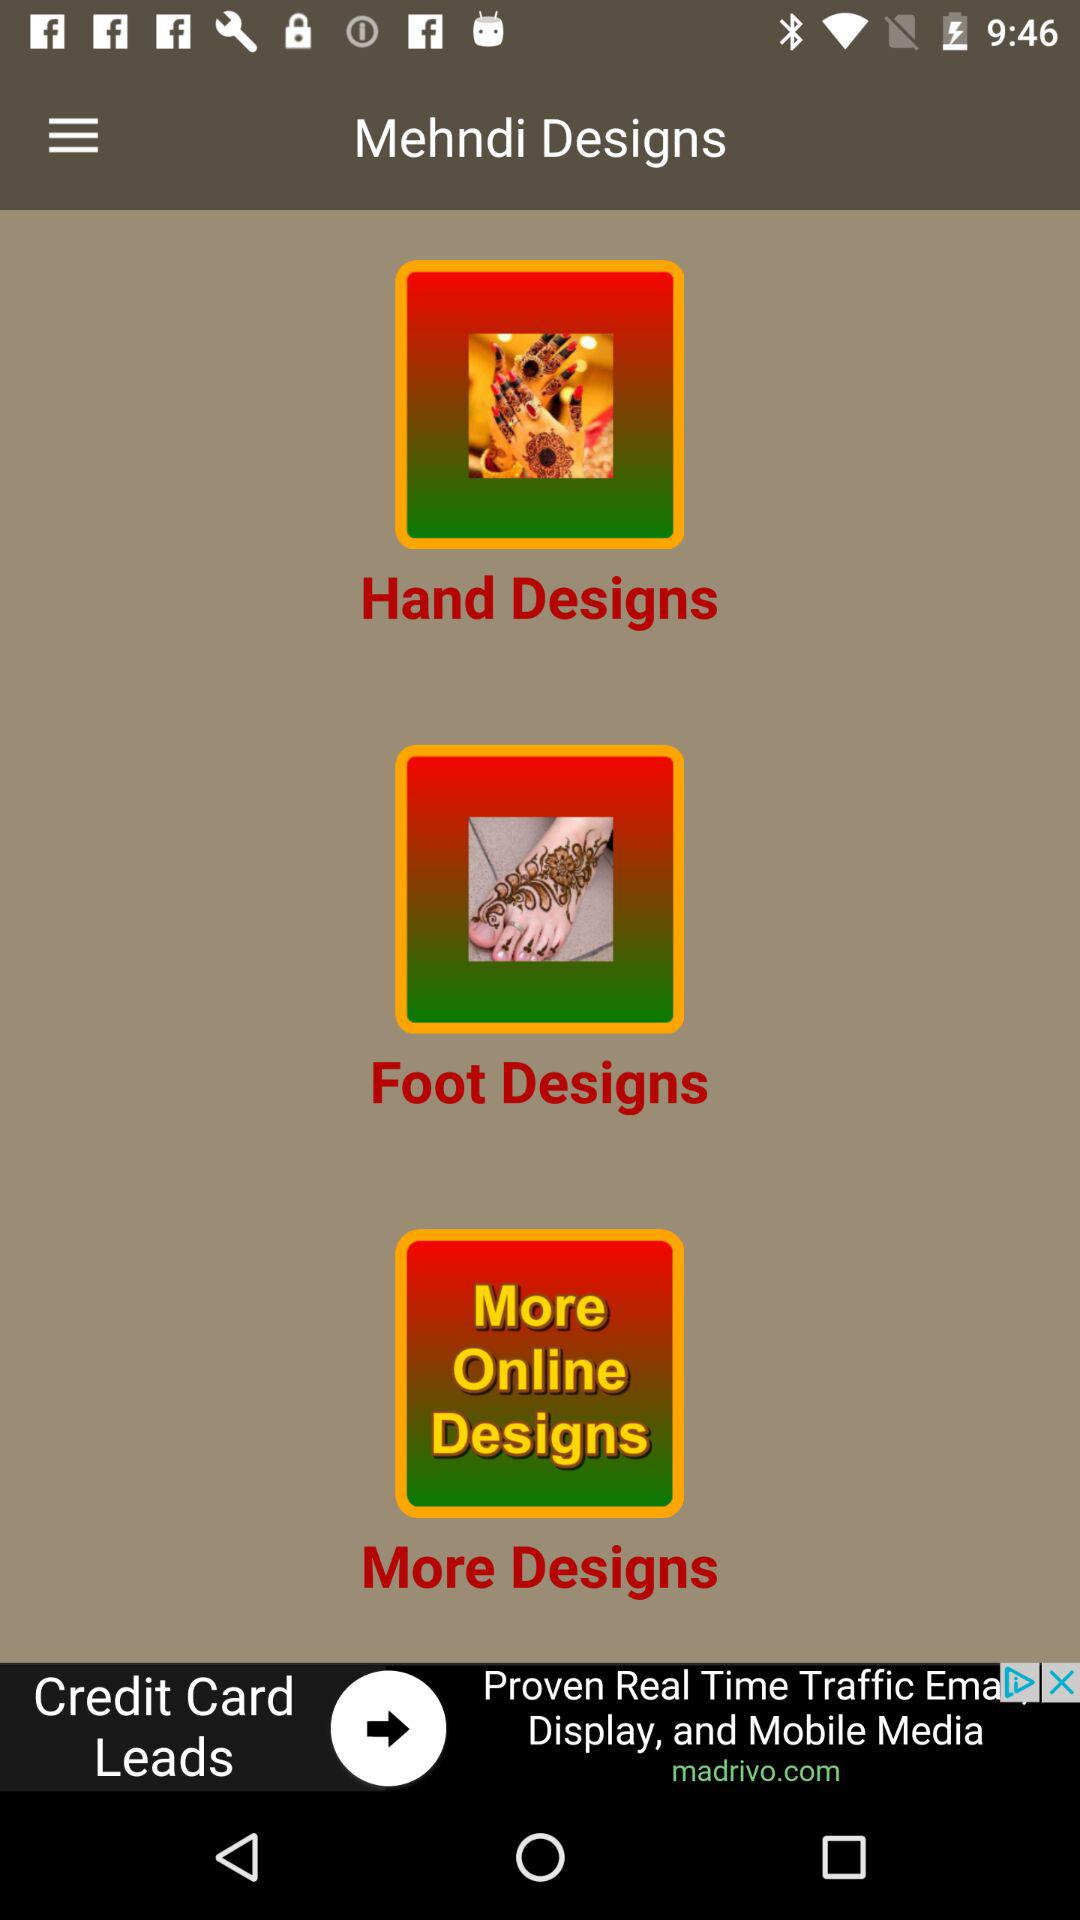How many designs are there in total?
Answer the question using a single word or phrase. 3 